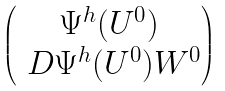Convert formula to latex. <formula><loc_0><loc_0><loc_500><loc_500>\begin{pmatrix} \Psi ^ { h } ( U ^ { 0 } ) \\ \ D \Psi ^ { h } ( U ^ { 0 } ) W ^ { 0 } \end{pmatrix}</formula> 